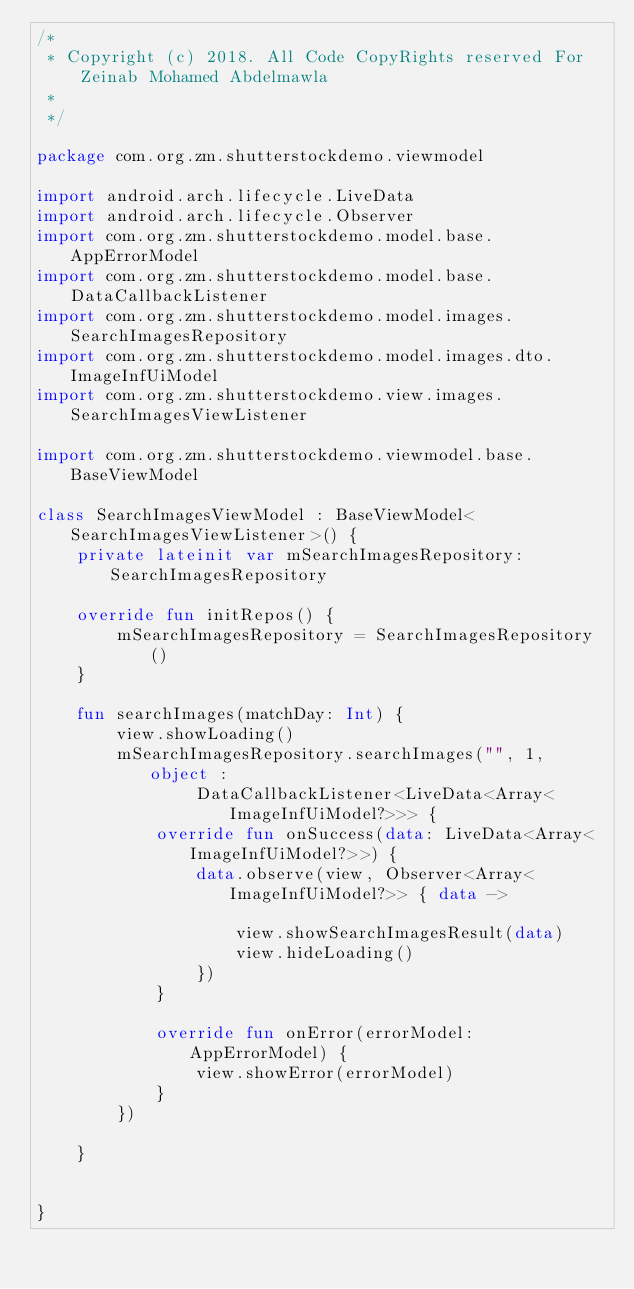<code> <loc_0><loc_0><loc_500><loc_500><_Kotlin_>/*
 * Copyright (c) 2018. All Code CopyRights reserved For Zeinab Mohamed Abdelmawla
 *
 */

package com.org.zm.shutterstockdemo.viewmodel

import android.arch.lifecycle.LiveData
import android.arch.lifecycle.Observer
import com.org.zm.shutterstockdemo.model.base.AppErrorModel
import com.org.zm.shutterstockdemo.model.base.DataCallbackListener
import com.org.zm.shutterstockdemo.model.images.SearchImagesRepository
import com.org.zm.shutterstockdemo.model.images.dto.ImageInfUiModel
import com.org.zm.shutterstockdemo.view.images.SearchImagesViewListener

import com.org.zm.shutterstockdemo.viewmodel.base.BaseViewModel

class SearchImagesViewModel : BaseViewModel<SearchImagesViewListener>() {
    private lateinit var mSearchImagesRepository: SearchImagesRepository

    override fun initRepos() {
        mSearchImagesRepository = SearchImagesRepository()
    }

    fun searchImages(matchDay: Int) {
        view.showLoading()
        mSearchImagesRepository.searchImages("", 1, object :
                DataCallbackListener<LiveData<Array<ImageInfUiModel?>>> {
            override fun onSuccess(data: LiveData<Array<ImageInfUiModel?>>) {
                data.observe(view, Observer<Array<ImageInfUiModel?>> { data ->

                    view.showSearchImagesResult(data)
                    view.hideLoading()
                })
            }

            override fun onError(errorModel: AppErrorModel) {
                view.showError(errorModel)
            }
        })

    }


}</code> 